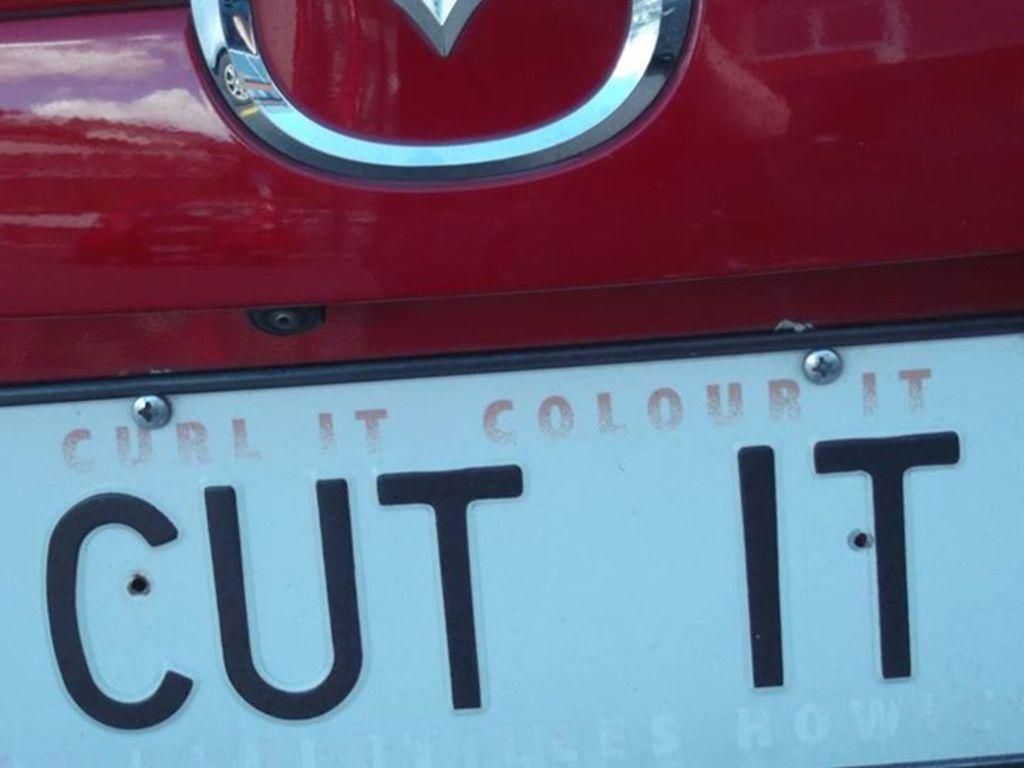<image>
Present a compact description of the photo's key features. a close up of a license plate reading Cut It 